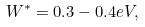Convert formula to latex. <formula><loc_0><loc_0><loc_500><loc_500>W ^ { * } = 0 . 3 - 0 . 4 e V ,</formula> 